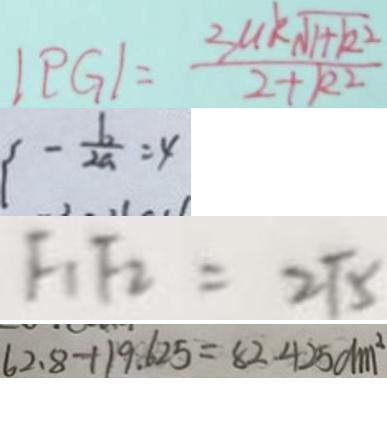Convert formula to latex. <formula><loc_0><loc_0><loc_500><loc_500>\vert P G \vert = \frac { 3 u k \sqrt { 1 + k ^ { 2 } } } { 2 + k ^ { 2 } } 
 - \frac { b } { 2 a } = 4 
 F _ { 1 } F _ { 2 } = 2 \sqrt { 5 } 
 6 2 . 8 + 1 9 . 6 2 5 = 8 2 . 4 2 5 d m ^ { 2 }</formula> 